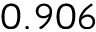Convert formula to latex. <formula><loc_0><loc_0><loc_500><loc_500>0 . 9 0 6</formula> 